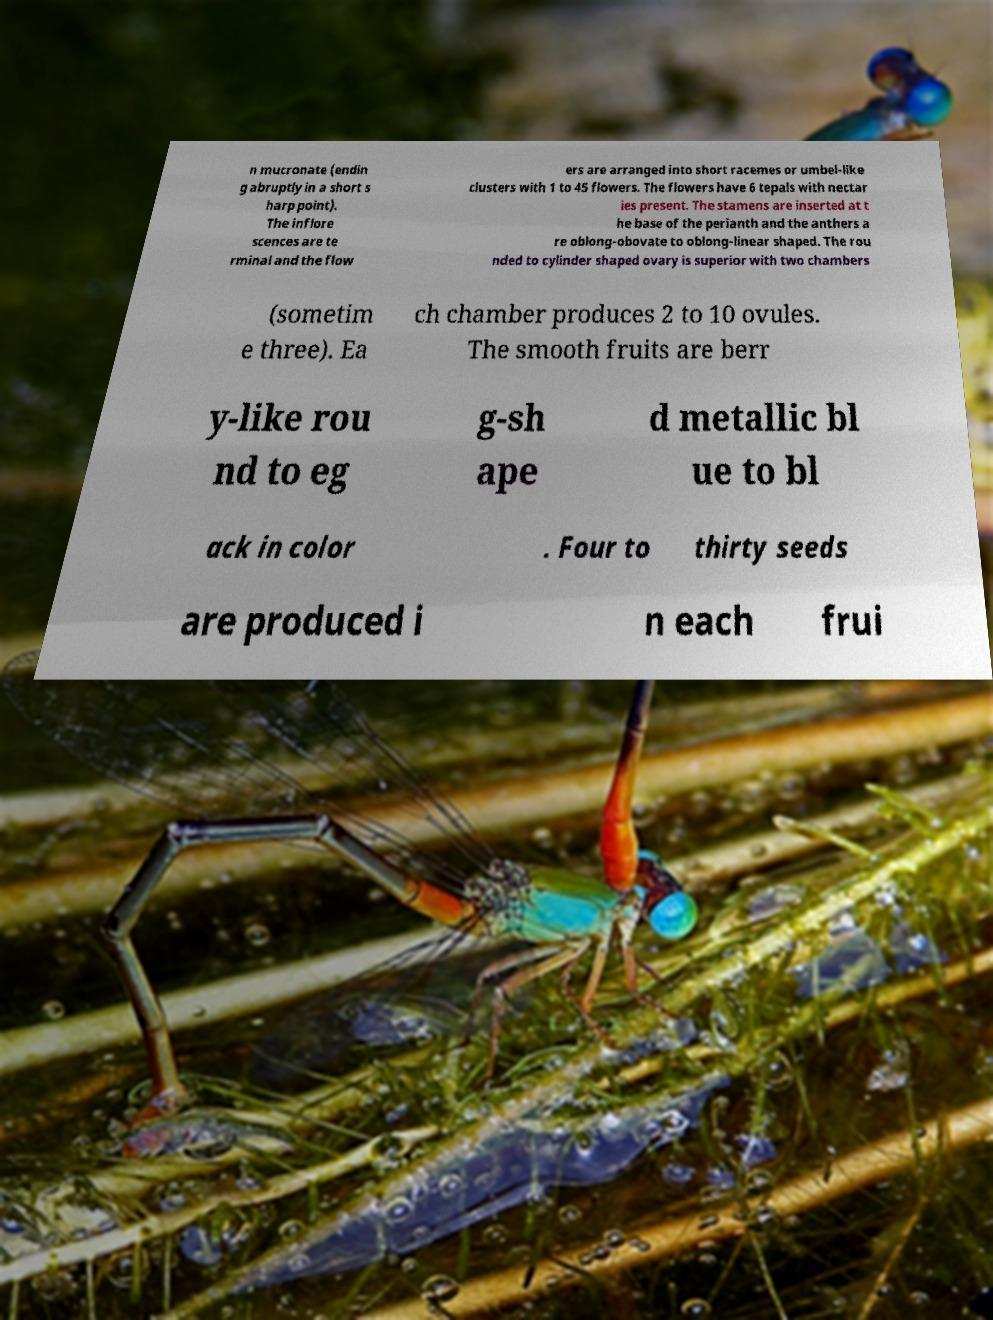Can you accurately transcribe the text from the provided image for me? n mucronate (endin g abruptly in a short s harp point). The inflore scences are te rminal and the flow ers are arranged into short racemes or umbel-like clusters with 1 to 45 flowers. The flowers have 6 tepals with nectar ies present. The stamens are inserted at t he base of the perianth and the anthers a re oblong-obovate to oblong-linear shaped. The rou nded to cylinder shaped ovary is superior with two chambers (sometim e three). Ea ch chamber produces 2 to 10 ovules. The smooth fruits are berr y-like rou nd to eg g-sh ape d metallic bl ue to bl ack in color . Four to thirty seeds are produced i n each frui 